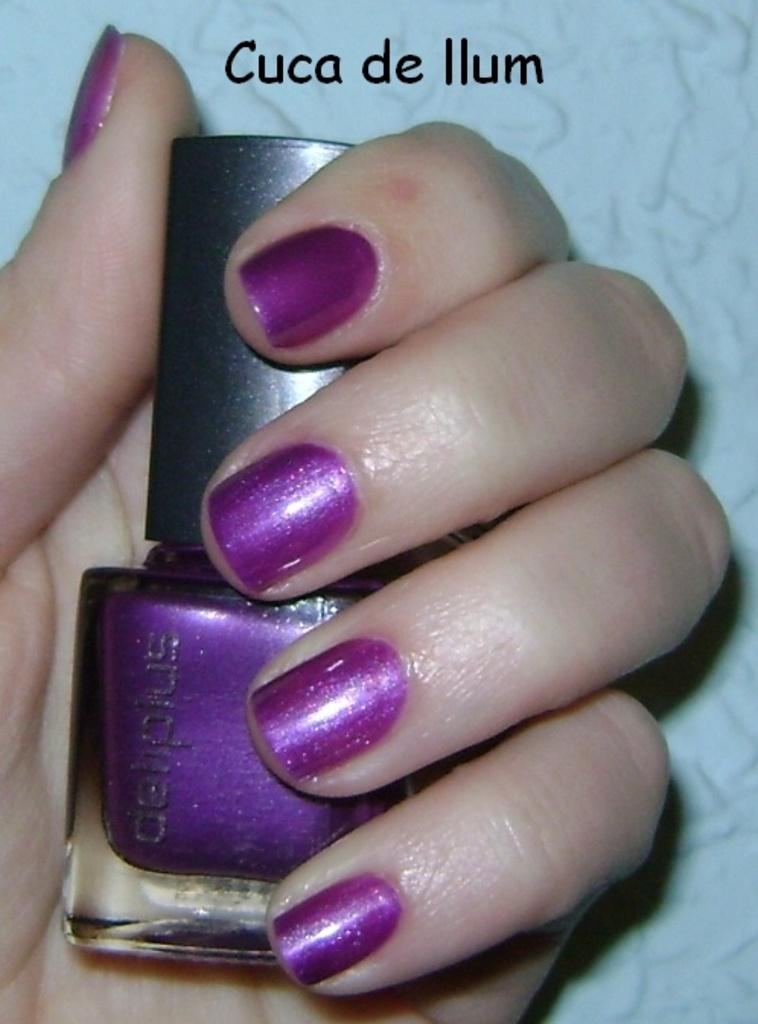What object is being held by a human hand in the image? The nail polish bottle is being held by a human hand in the image. What is the main subject of the image? The main subject of the image is the nail polish bottle. Is there any text present in the image? Yes, there is text at the top of the image. How many cars can be seen in the image? There are no cars present in the image. What type of string is being used to apply the nail polish in the image? There is no string being used to apply the nail polish in the image; a human hand is holding the bottle. 